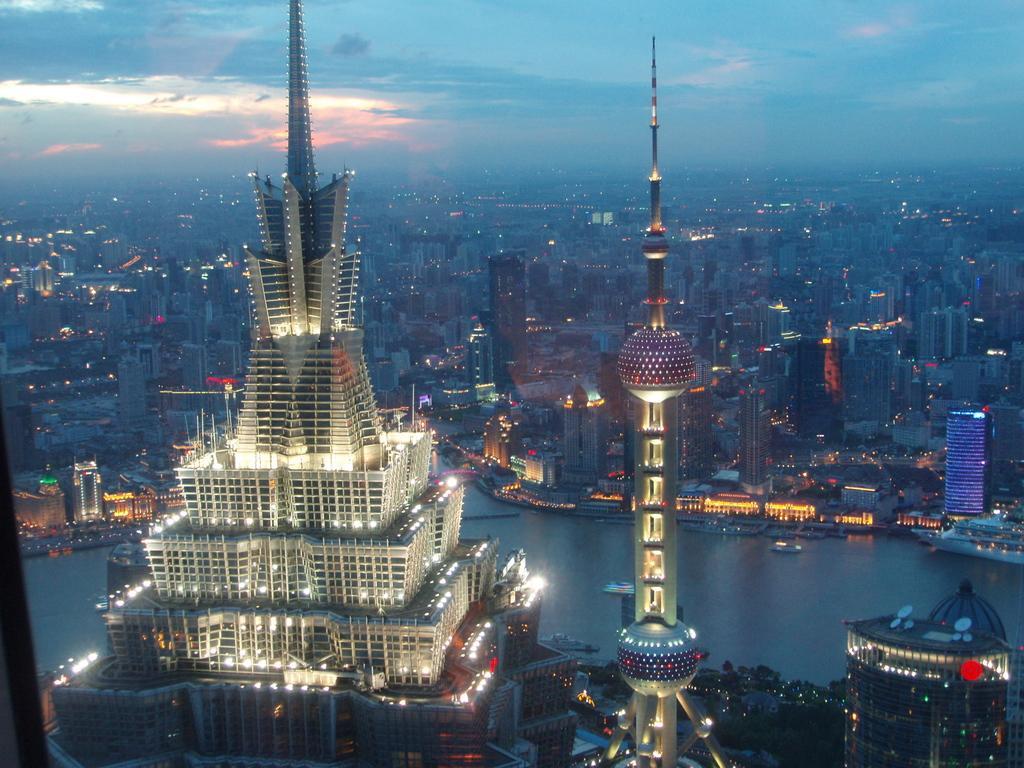Can you describe this image briefly? In this image I can see buildings. There are lights, trees and in the background there is sky. 